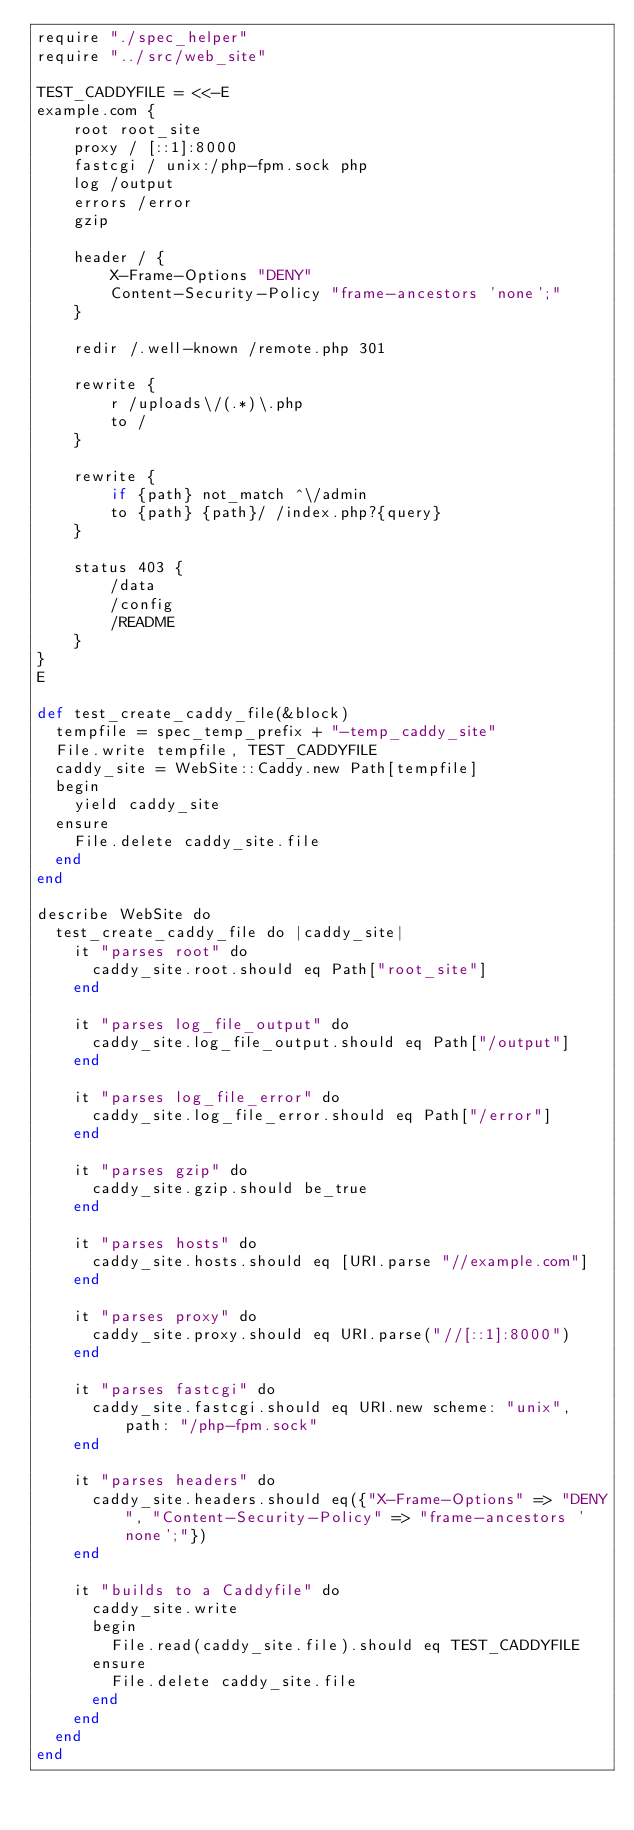Convert code to text. <code><loc_0><loc_0><loc_500><loc_500><_Crystal_>require "./spec_helper"
require "../src/web_site"

TEST_CADDYFILE = <<-E
example.com {
    root root_site
    proxy / [::1]:8000
    fastcgi / unix:/php-fpm.sock php
    log /output
    errors /error
    gzip

    header / {
        X-Frame-Options "DENY"
        Content-Security-Policy "frame-ancestors 'none';"
    }

    redir /.well-known /remote.php 301

    rewrite {
        r /uploads\/(.*)\.php
        to /
    }

    rewrite {
        if {path} not_match ^\/admin
        to {path} {path}/ /index.php?{query}
    }

    status 403 {
        /data
        /config
        /README
    }
}
E

def test_create_caddy_file(&block)
  tempfile = spec_temp_prefix + "-temp_caddy_site"
  File.write tempfile, TEST_CADDYFILE
  caddy_site = WebSite::Caddy.new Path[tempfile]
  begin
    yield caddy_site
  ensure
    File.delete caddy_site.file
  end
end

describe WebSite do
  test_create_caddy_file do |caddy_site|
    it "parses root" do
      caddy_site.root.should eq Path["root_site"]
    end

    it "parses log_file_output" do
      caddy_site.log_file_output.should eq Path["/output"]
    end

    it "parses log_file_error" do
      caddy_site.log_file_error.should eq Path["/error"]
    end

    it "parses gzip" do
      caddy_site.gzip.should be_true
    end

    it "parses hosts" do
      caddy_site.hosts.should eq [URI.parse "//example.com"]
    end

    it "parses proxy" do
      caddy_site.proxy.should eq URI.parse("//[::1]:8000")
    end

    it "parses fastcgi" do
      caddy_site.fastcgi.should eq URI.new scheme: "unix", path: "/php-fpm.sock"
    end

    it "parses headers" do
      caddy_site.headers.should eq({"X-Frame-Options" => "DENY", "Content-Security-Policy" => "frame-ancestors 'none';"})
    end

    it "builds to a Caddyfile" do
      caddy_site.write
      begin
        File.read(caddy_site.file).should eq TEST_CADDYFILE
      ensure
        File.delete caddy_site.file
      end
    end
  end
end
</code> 